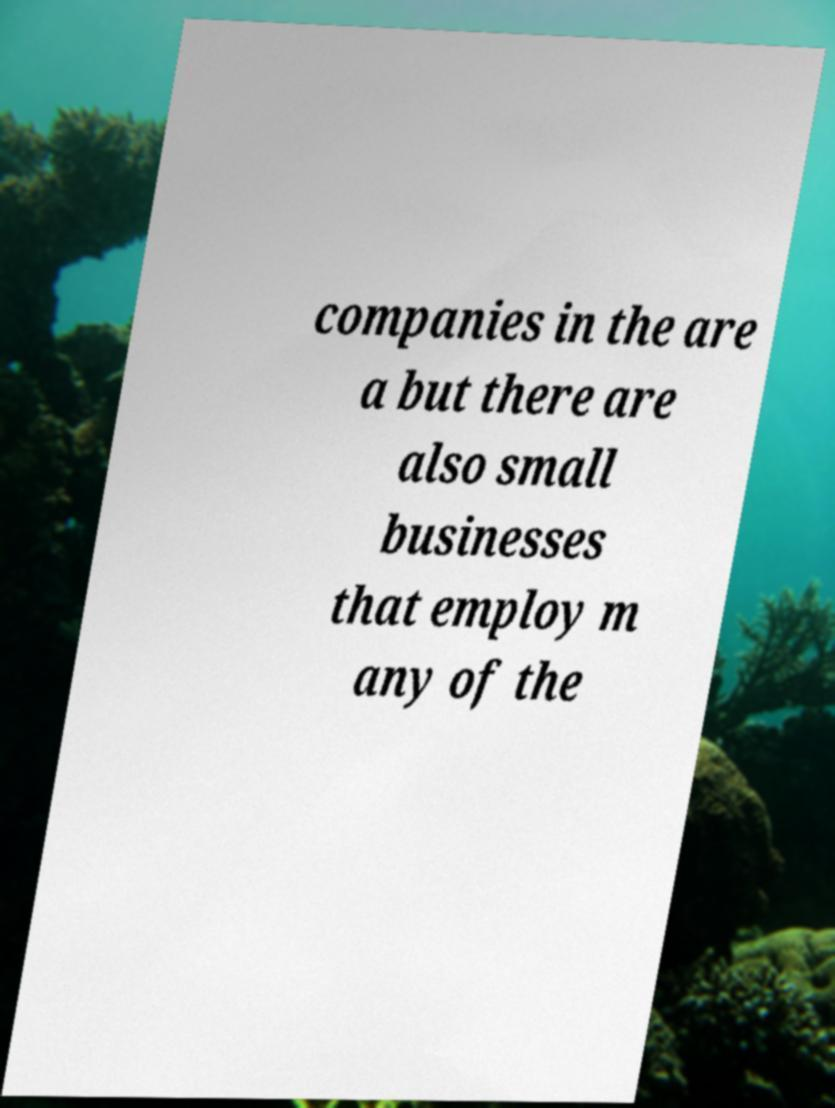For documentation purposes, I need the text within this image transcribed. Could you provide that? companies in the are a but there are also small businesses that employ m any of the 